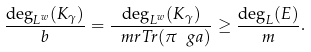Convert formula to latex. <formula><loc_0><loc_0><loc_500><loc_500>\frac { \deg _ { L ^ { w } } ( K _ { \gamma } ) } { b } = \frac { \deg _ { L ^ { w } } ( K _ { \gamma } ) } { \ m r { T r } ( \pi _ { \ } g a ) } \geq \frac { \deg _ { L } ( E ) } { m } .</formula> 